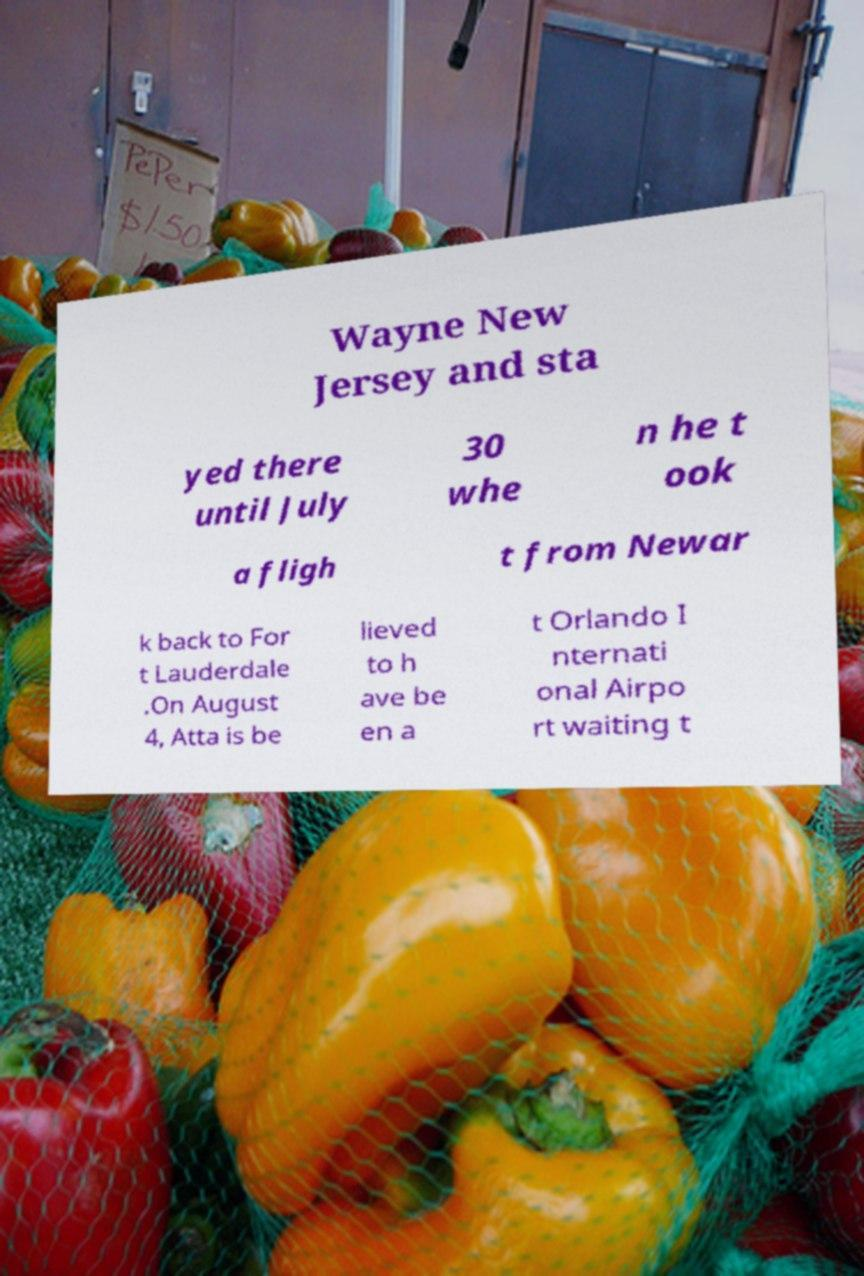Can you accurately transcribe the text from the provided image for me? Wayne New Jersey and sta yed there until July 30 whe n he t ook a fligh t from Newar k back to For t Lauderdale .On August 4, Atta is be lieved to h ave be en a t Orlando I nternati onal Airpo rt waiting t 